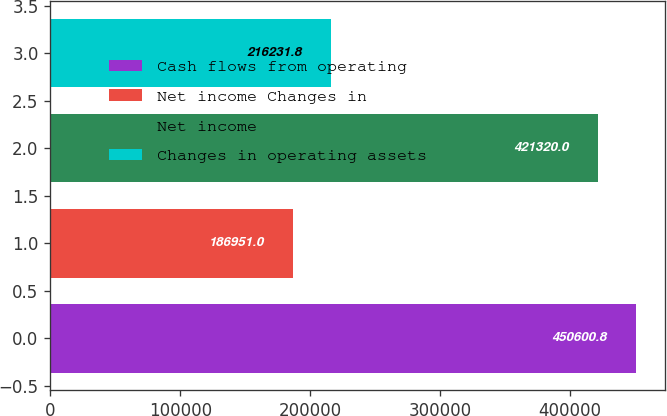<chart> <loc_0><loc_0><loc_500><loc_500><bar_chart><fcel>Cash flows from operating<fcel>Net income Changes in<fcel>Net income<fcel>Changes in operating assets<nl><fcel>450601<fcel>186951<fcel>421320<fcel>216232<nl></chart> 